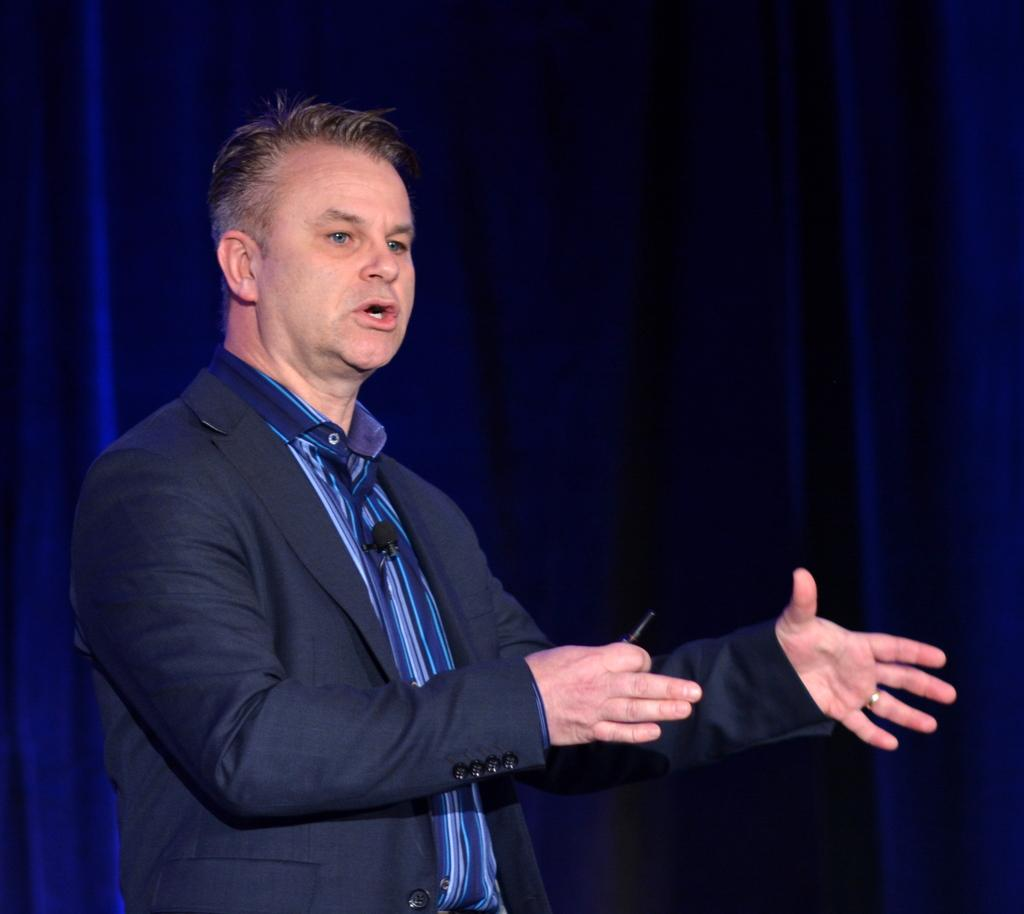Who is present in the image? There is a person in the image. What is the person wearing? The person is wearing a blue jacket. What is the person doing in the image? The person is talking. What can be seen in the background of the image? There are blue curtains in the background of the image. What book is the person reading in the image? There is no book present in the image, and the person is talking, not reading. 